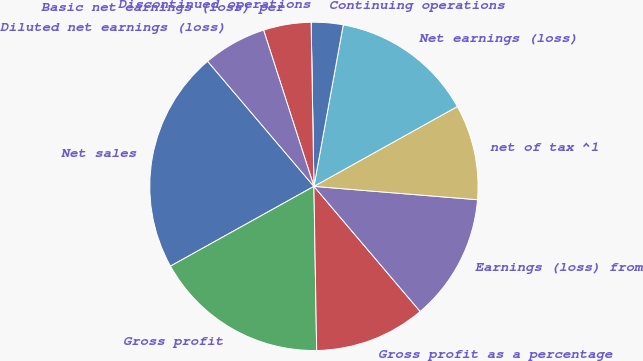<chart> <loc_0><loc_0><loc_500><loc_500><pie_chart><fcel>Net sales<fcel>Gross profit<fcel>Gross profit as a percentage<fcel>Earnings (loss) from<fcel>net of tax ^1<fcel>Net earnings (loss)<fcel>Continuing operations<fcel>Discontinued operations<fcel>Basic net earnings (loss) per<fcel>Diluted net earnings (loss)<nl><fcel>21.87%<fcel>17.19%<fcel>10.94%<fcel>12.5%<fcel>9.38%<fcel>14.06%<fcel>3.13%<fcel>0.0%<fcel>4.69%<fcel>6.25%<nl></chart> 